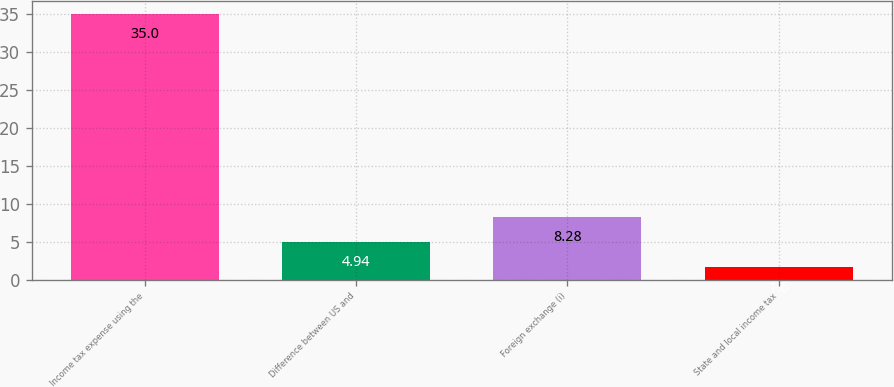Convert chart to OTSL. <chart><loc_0><loc_0><loc_500><loc_500><bar_chart><fcel>Income tax expense using the<fcel>Difference between US and<fcel>Foreign exchange (i)<fcel>State and local income tax<nl><fcel>35<fcel>4.94<fcel>8.28<fcel>1.6<nl></chart> 